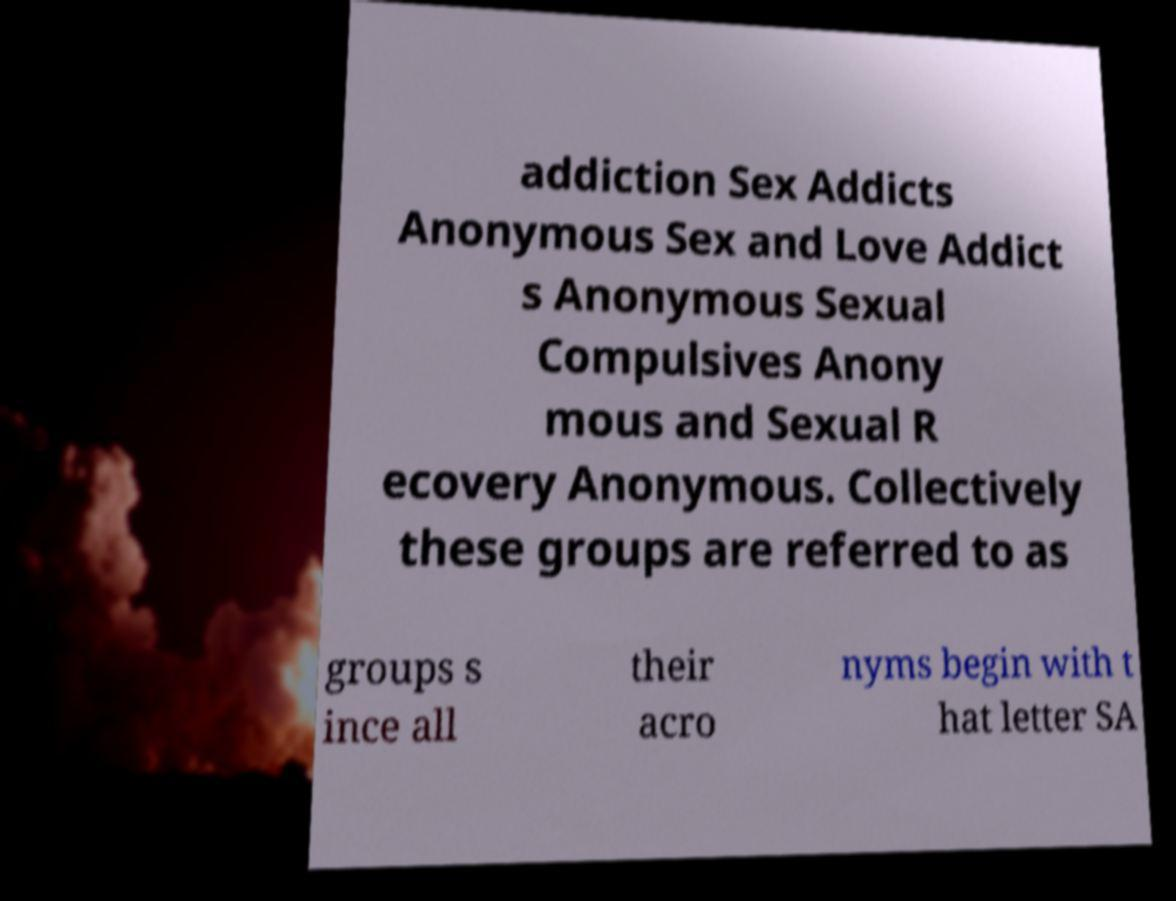There's text embedded in this image that I need extracted. Can you transcribe it verbatim? addiction Sex Addicts Anonymous Sex and Love Addict s Anonymous Sexual Compulsives Anony mous and Sexual R ecovery Anonymous. Collectively these groups are referred to as groups s ince all their acro nyms begin with t hat letter SA 